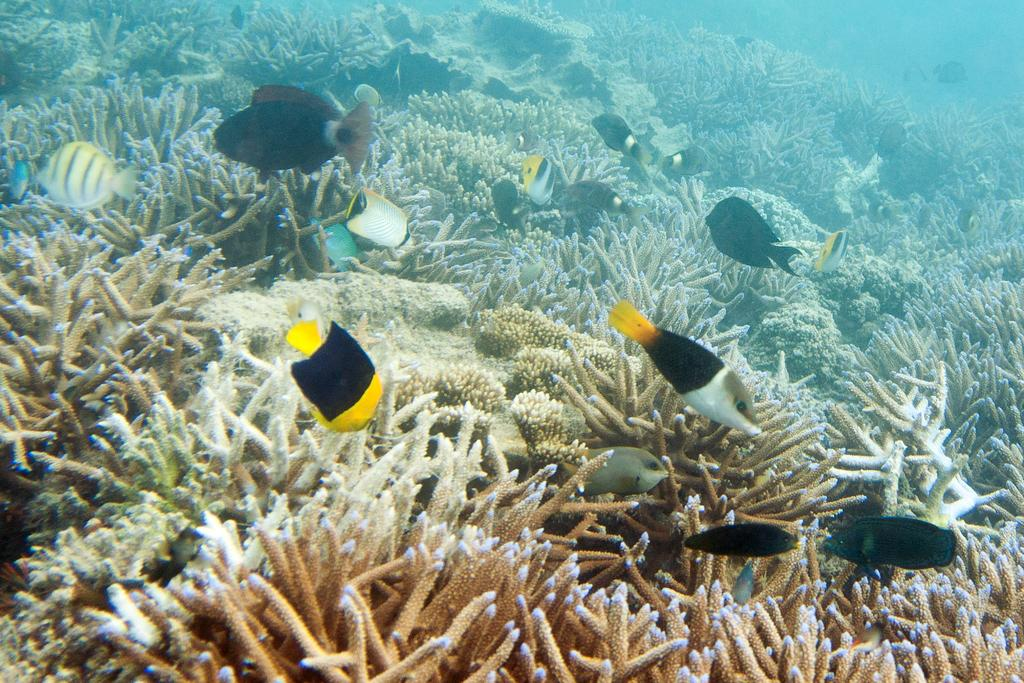What type of environment is shown in the image? The image depicts an underwater environment. What type of marine life can be seen in the image? There are fish visible in the image. What type of picture frame is used to display the image? The provided facts do not mention any picture frame or border around the image, so it cannot be determined from the information given. 